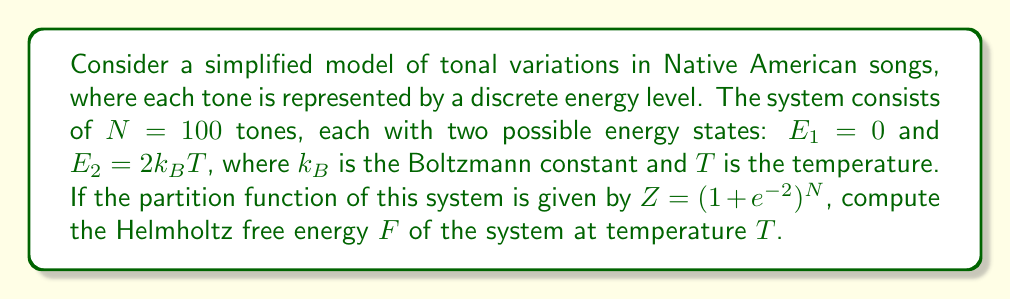Help me with this question. To solve this problem, we'll follow these steps:

1) Recall the relationship between the partition function $Z$ and the Helmholtz free energy $F$:

   $$F = -k_BT \ln Z$$

2) We are given that $Z = (1 + e^{-2})^N$ and $N = 100$. Let's substitute these:

   $$F = -k_BT \ln [(1 + e^{-2})^{100}]$$

3) Using the properties of logarithms, we can simplify:

   $$F = -100k_BT \ln (1 + e^{-2})$$

4) The value of $e^{-2}$ is approximately 0.1353. So:

   $$F \approx -100k_BT \ln (1.1353)$$

5) Calculate $\ln (1.1353)$:

   $$F \approx -100k_BT \cdot 0.1269$$

6) Simplify:

   $$F \approx -12.69k_BT$$

This is our final expression for the Helmholtz free energy of the system.
Answer: $F \approx -12.69k_BT$ 